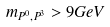<formula> <loc_0><loc_0><loc_500><loc_500>m _ { P ^ { 0 } , P ^ { 3 } } > 9 G e V</formula> 